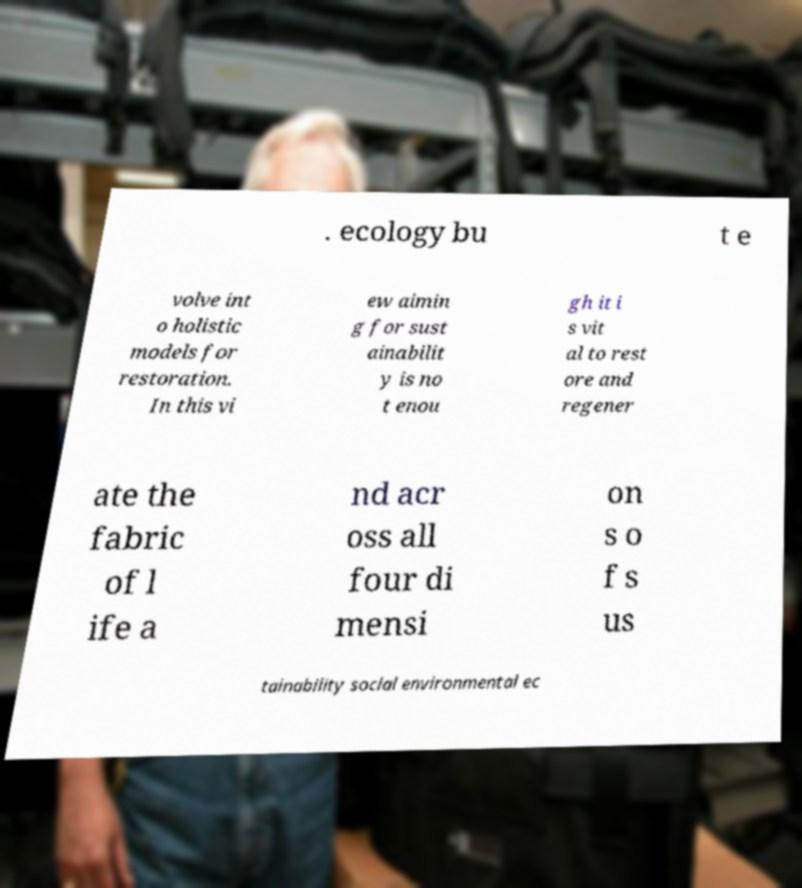There's text embedded in this image that I need extracted. Can you transcribe it verbatim? . ecology bu t e volve int o holistic models for restoration. In this vi ew aimin g for sust ainabilit y is no t enou gh it i s vit al to rest ore and regener ate the fabric of l ife a nd acr oss all four di mensi on s o f s us tainability social environmental ec 